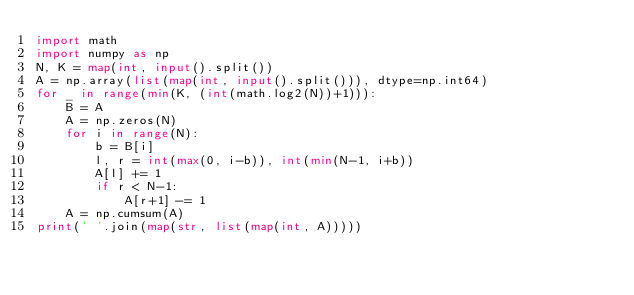Convert code to text. <code><loc_0><loc_0><loc_500><loc_500><_Python_>import math
import numpy as np
N, K = map(int, input().split())
A = np.array(list(map(int, input().split())), dtype=np.int64)
for _ in range(min(K, (int(math.log2(N))+1))):
    B = A
    A = np.zeros(N)
    for i in range(N):
        b = B[i]
        l, r = int(max(0, i-b)), int(min(N-1, i+b))
        A[l] += 1
        if r < N-1:
            A[r+1] -= 1
    A = np.cumsum(A)
print(' '.join(map(str, list(map(int, A)))))
</code> 